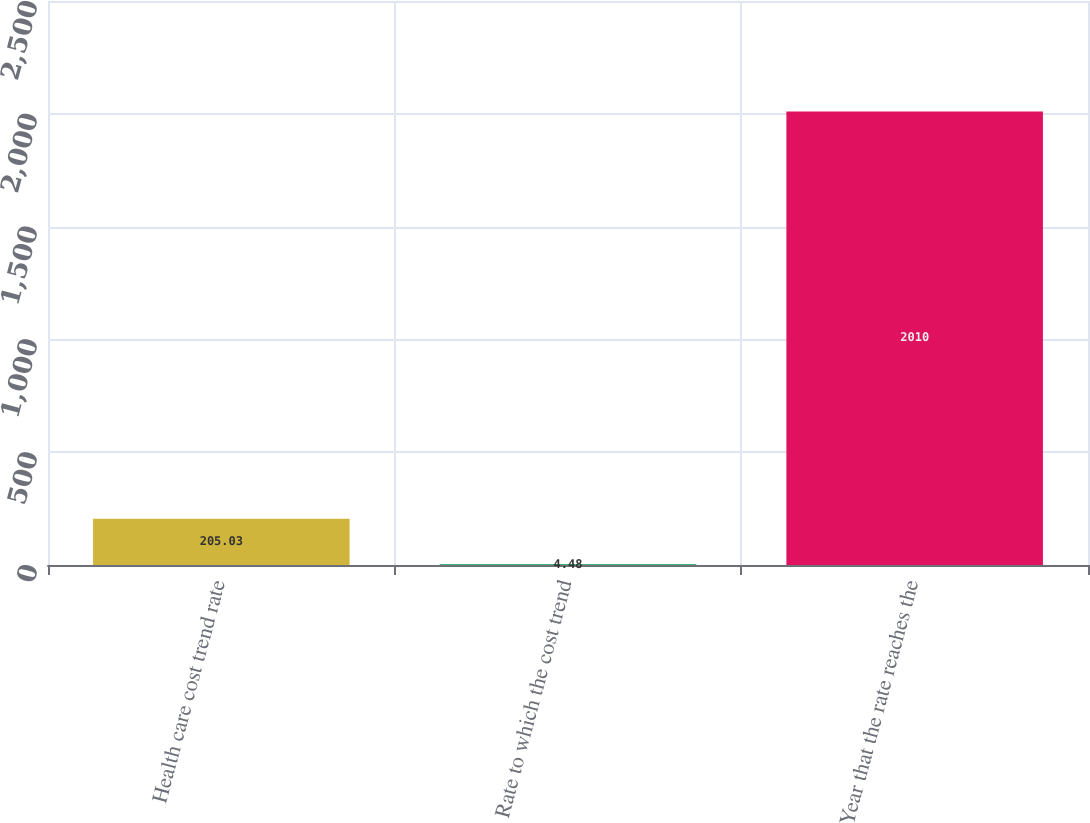Convert chart to OTSL. <chart><loc_0><loc_0><loc_500><loc_500><bar_chart><fcel>Health care cost trend rate<fcel>Rate to which the cost trend<fcel>Year that the rate reaches the<nl><fcel>205.03<fcel>4.48<fcel>2010<nl></chart> 